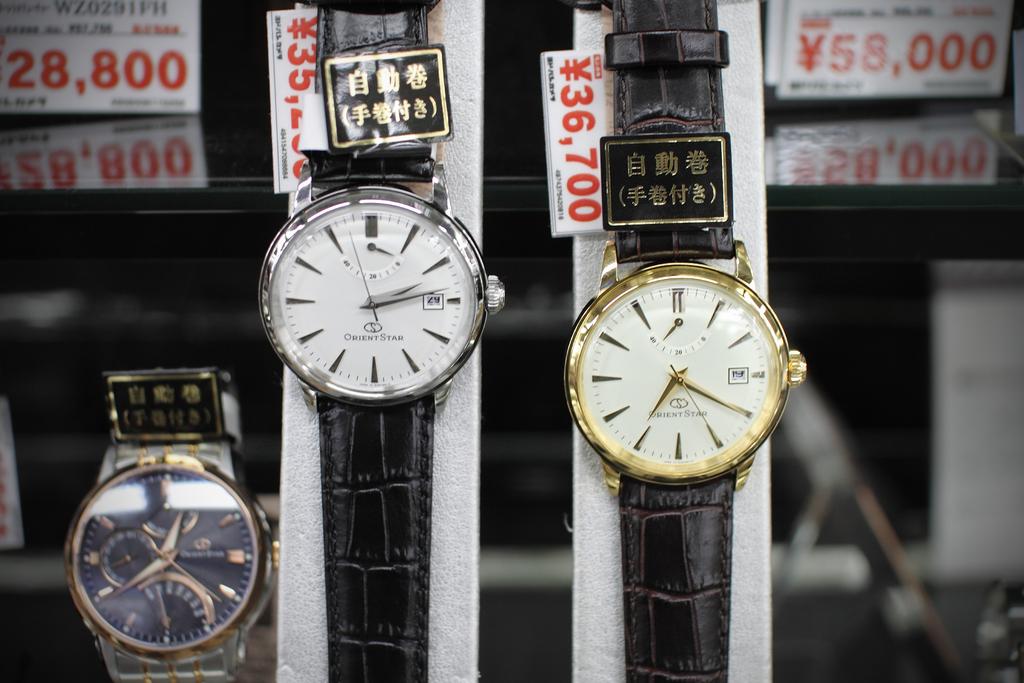What time does the gold watch say?
Provide a short and direct response. 7:20. What time does the middle watch say?
Keep it short and to the point. 2:13. 